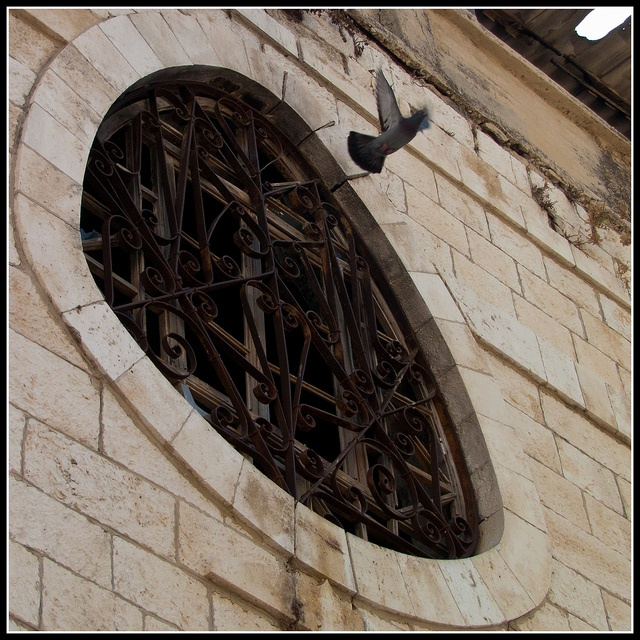Describe the objects in this image and their specific colors. I can see a bird in black, gray, and darkgray tones in this image. 